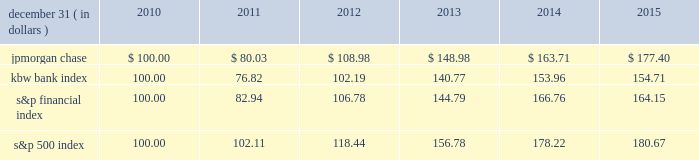Jpmorgan chase & co./2015 annual report 67 five-year stock performance the table and graph compare the five-year cumulative total return for jpmorgan chase & co .
( 201cjpmorgan chase 201d or the 201cfirm 201d ) common stock with the cumulative return of the s&p 500 index , the kbw bank index and the s&p financial index .
The s&p 500 index is a commonly referenced united states of america ( 201cu.s . 201d ) equity benchmark consisting of leading companies from different economic sectors .
The kbw bank index seeks to reflect the performance of banks and thrifts that are publicly traded in the u.s .
And is composed of 24 leading national money center and regional banks and thrifts .
The s&p financial index is an index of 87 financial companies , all of which are components of the s&p 500 .
The firm is a component of all three industry indices .
The table and graph assume simultaneous investments of $ 100 on december 31 , 2010 , in jpmorgan chase common stock and in each of the above indices .
The comparison assumes that all dividends are reinvested .
December 31 , ( in dollars ) 2010 2011 2012 2013 2014 2015 .
December 31 , ( in dollars ) .
What was the 5 year return of the s&p 500 index? 
Computations: ((180.67 - 100) / 100)
Answer: 0.8067. 